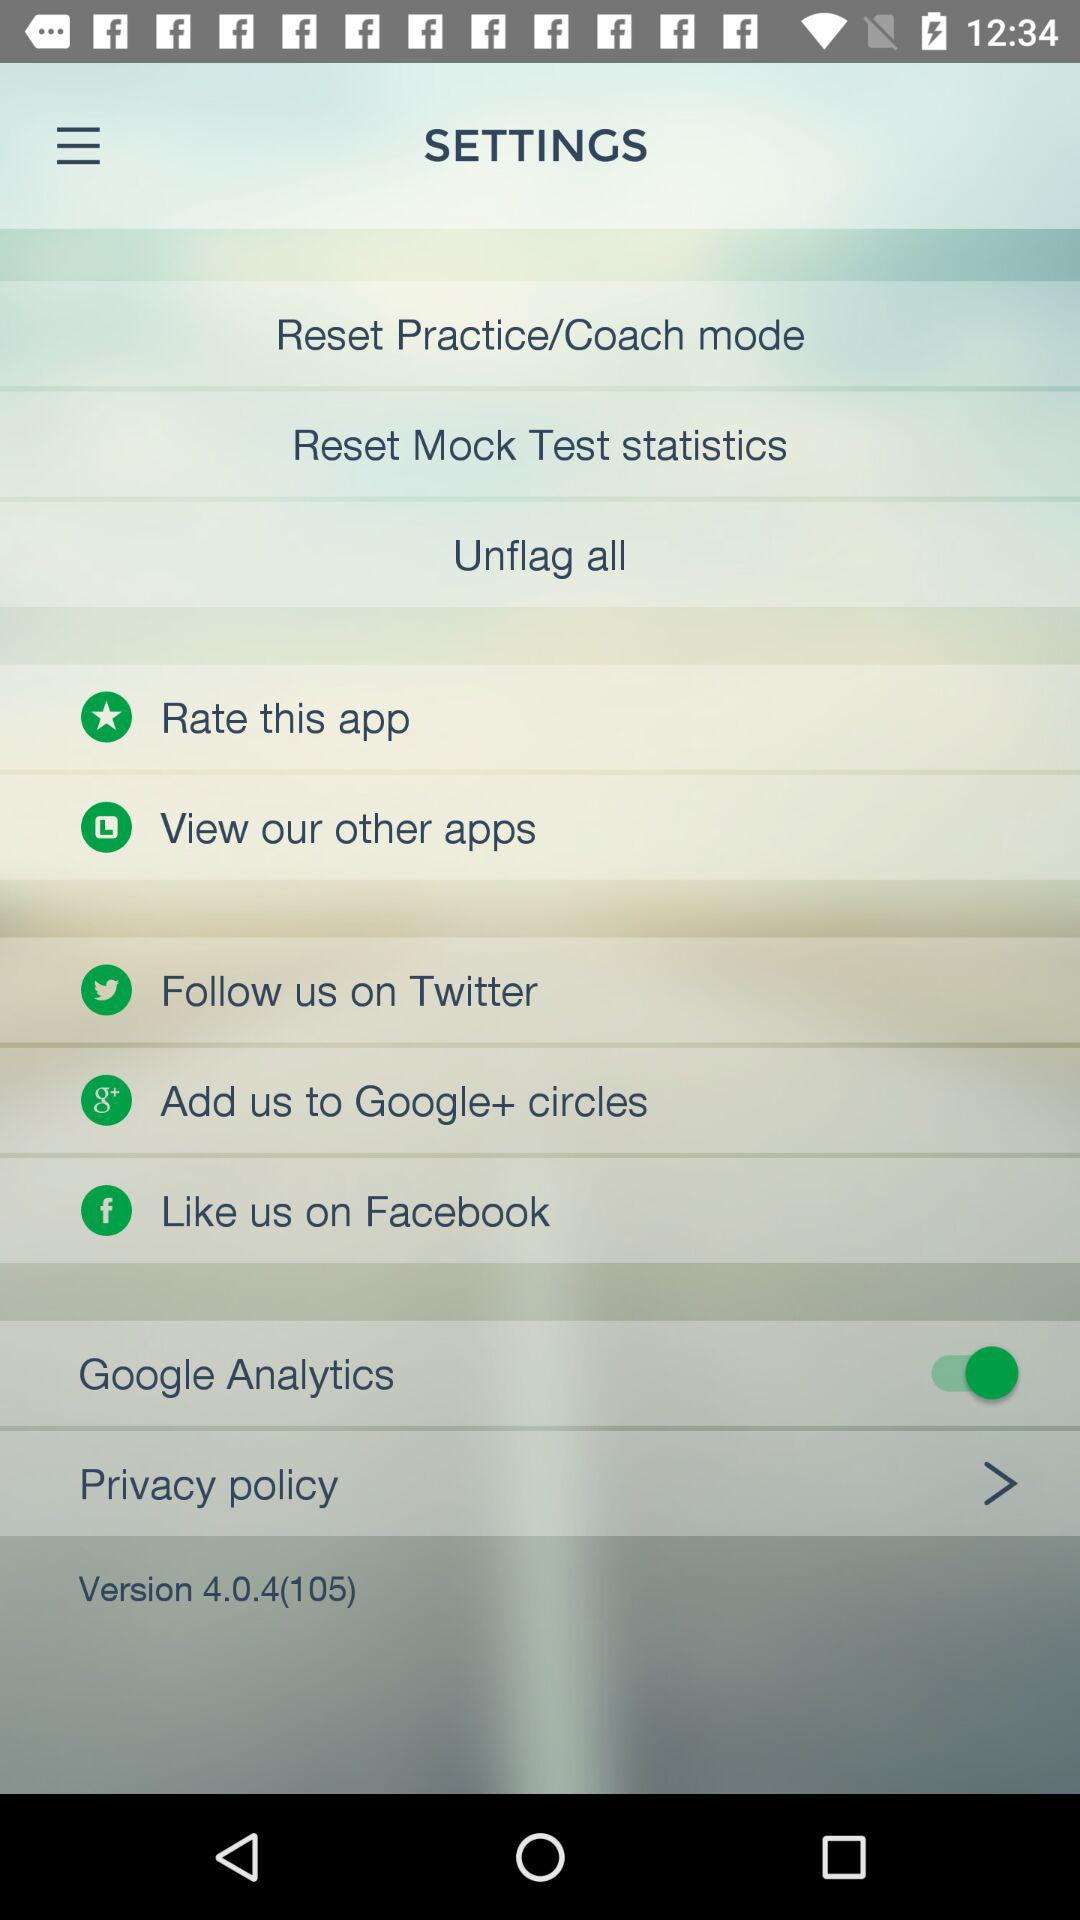What is the status of Google Analytics? The status is on. 